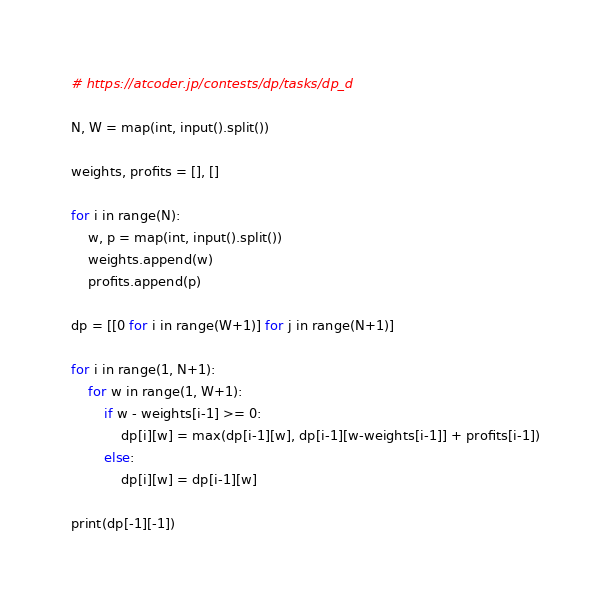Convert code to text. <code><loc_0><loc_0><loc_500><loc_500><_Python_># https://atcoder.jp/contests/dp/tasks/dp_d

N, W = map(int, input().split())

weights, profits = [], []

for i in range(N):
    w, p = map(int, input().split())
    weights.append(w)
    profits.append(p)

dp = [[0 for i in range(W+1)] for j in range(N+1)]

for i in range(1, N+1):
    for w in range(1, W+1):
        if w - weights[i-1] >= 0:
            dp[i][w] = max(dp[i-1][w], dp[i-1][w-weights[i-1]] + profits[i-1])
        else:
            dp[i][w] = dp[i-1][w]

print(dp[-1][-1])
</code> 